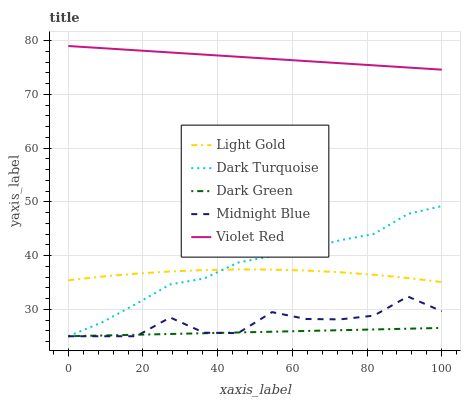Does Dark Green have the minimum area under the curve?
Answer yes or no. Yes. Does Violet Red have the maximum area under the curve?
Answer yes or no. Yes. Does Light Gold have the minimum area under the curve?
Answer yes or no. No. Does Light Gold have the maximum area under the curve?
Answer yes or no. No. Is Dark Green the smoothest?
Answer yes or no. Yes. Is Midnight Blue the roughest?
Answer yes or no. Yes. Is Violet Red the smoothest?
Answer yes or no. No. Is Violet Red the roughest?
Answer yes or no. No. Does Dark Turquoise have the lowest value?
Answer yes or no. Yes. Does Light Gold have the lowest value?
Answer yes or no. No. Does Violet Red have the highest value?
Answer yes or no. Yes. Does Light Gold have the highest value?
Answer yes or no. No. Is Light Gold less than Violet Red?
Answer yes or no. Yes. Is Light Gold greater than Dark Green?
Answer yes or no. Yes. Does Dark Turquoise intersect Light Gold?
Answer yes or no. Yes. Is Dark Turquoise less than Light Gold?
Answer yes or no. No. Is Dark Turquoise greater than Light Gold?
Answer yes or no. No. Does Light Gold intersect Violet Red?
Answer yes or no. No. 